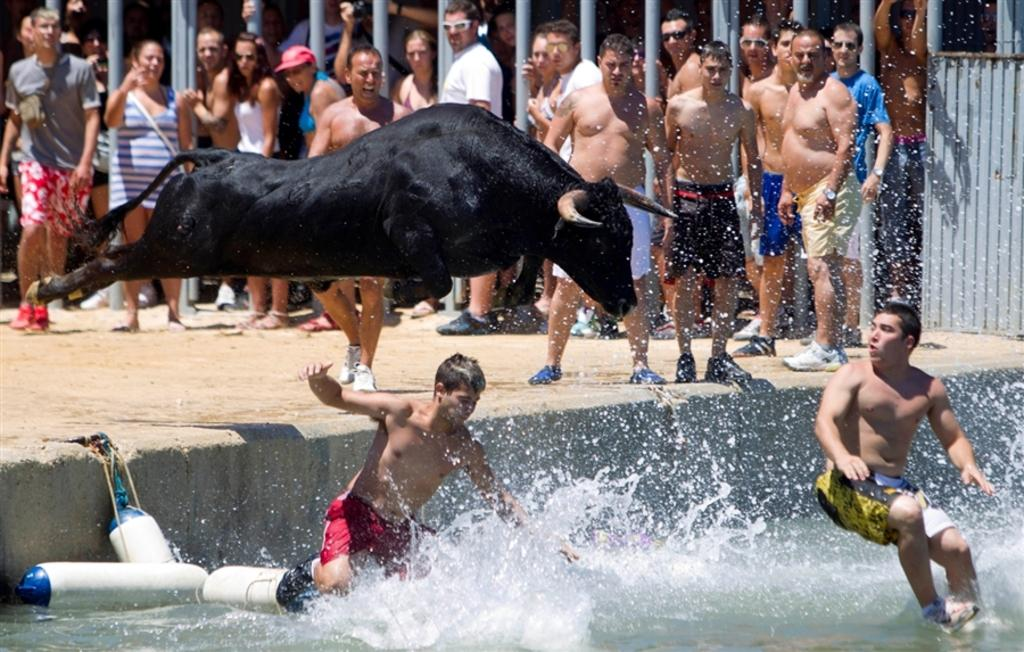What is the main subject of the image? There is a group of people in the image. Are there any animals present in the image? Yes, there is a bull in the image. What are some people doing in the image? Some people are in the water. What can be seen in the background of the image? There are metal rods visible in the background of the image. What type of cars can be seen in the image? There are no cars present in the image. What force is being applied to the bull in the image? There is no force being applied to the bull in the image; it is simply standing there. 